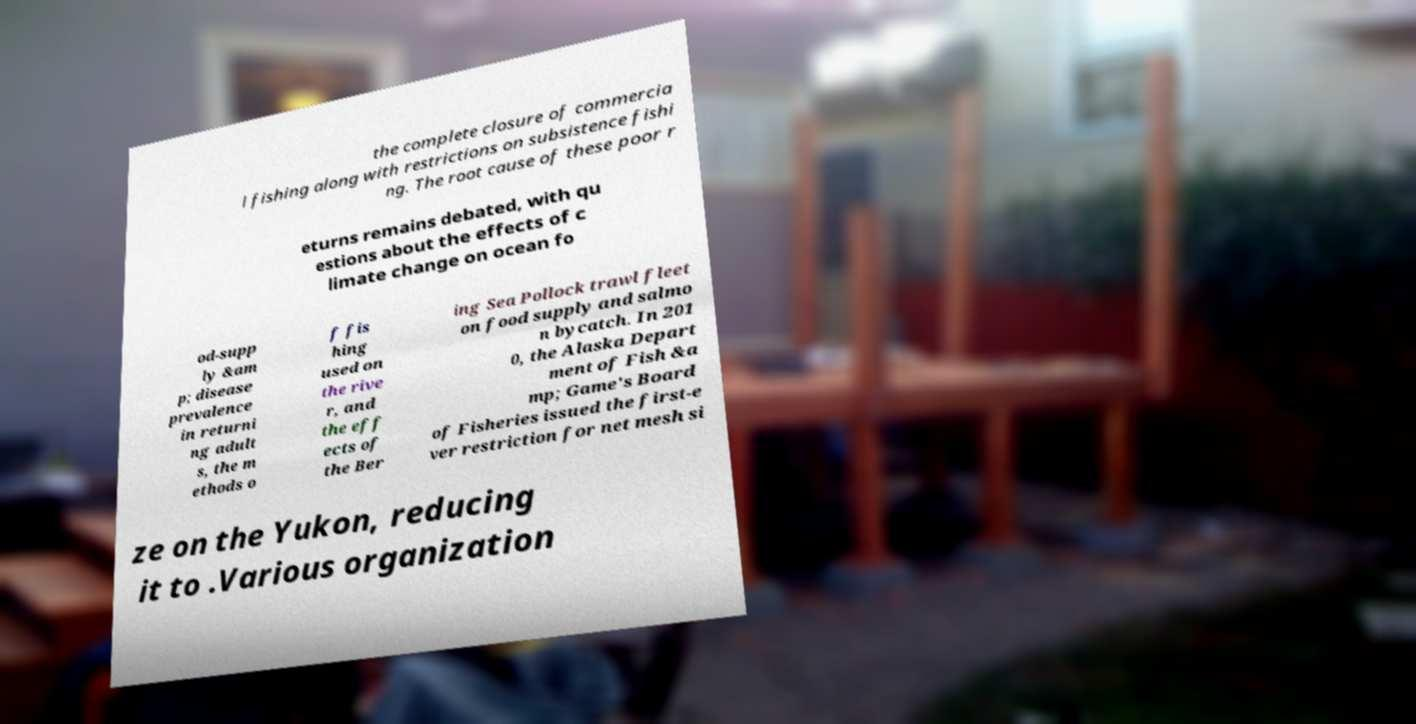I need the written content from this picture converted into text. Can you do that? the complete closure of commercia l fishing along with restrictions on subsistence fishi ng. The root cause of these poor r eturns remains debated, with qu estions about the effects of c limate change on ocean fo od-supp ly &am p; disease prevalence in returni ng adult s, the m ethods o f fis hing used on the rive r, and the eff ects of the Ber ing Sea Pollock trawl fleet on food supply and salmo n bycatch. In 201 0, the Alaska Depart ment of Fish &a mp; Game's Board of Fisheries issued the first-e ver restriction for net mesh si ze on the Yukon, reducing it to .Various organization 